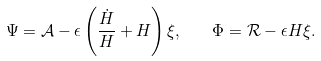Convert formula to latex. <formula><loc_0><loc_0><loc_500><loc_500>\Psi = \mathcal { A } - \epsilon \left ( \frac { \dot { H } } { H } + H \right ) \xi , \quad \Phi = \mathcal { R } - \epsilon H \xi .</formula> 